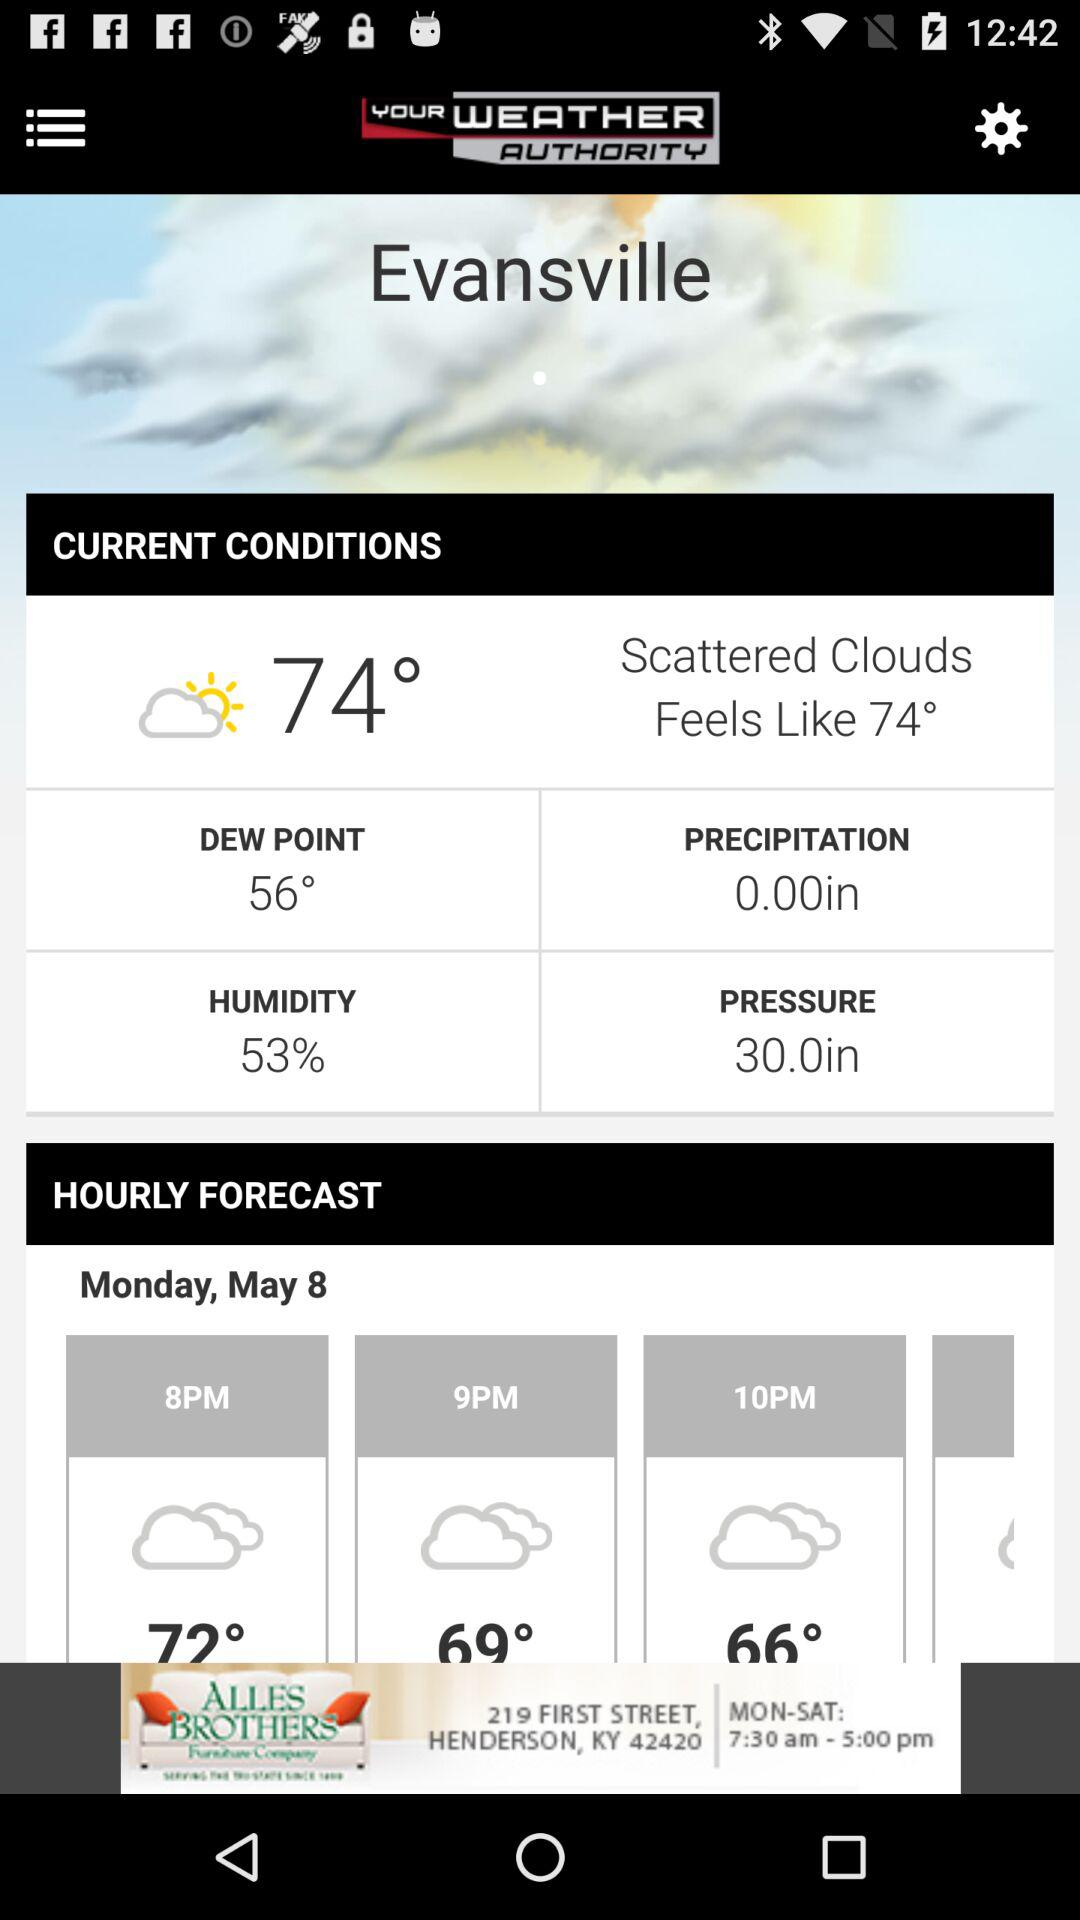How many more degrees is the current temperature than the dew point?
Answer the question using a single word or phrase. 18 